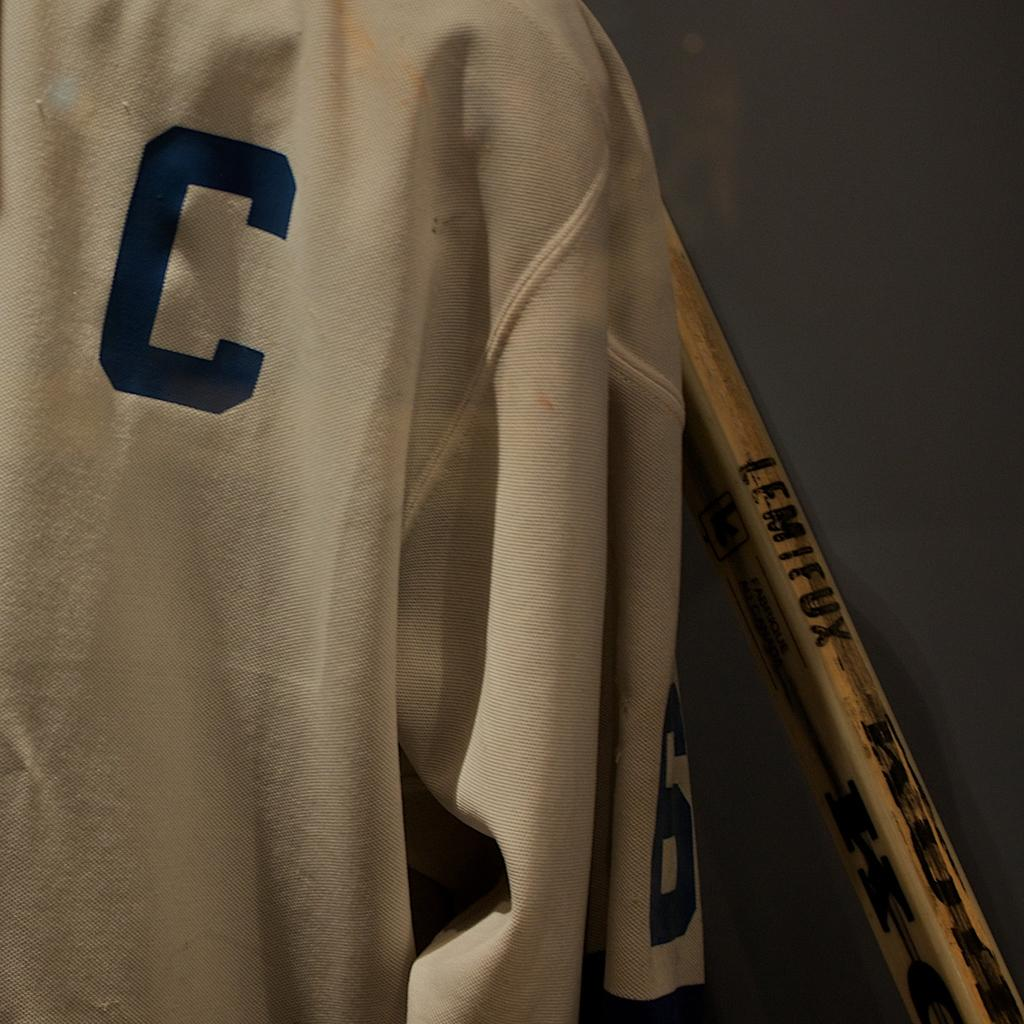<image>
Write a terse but informative summary of the picture. a jersey that has the letter C on it 